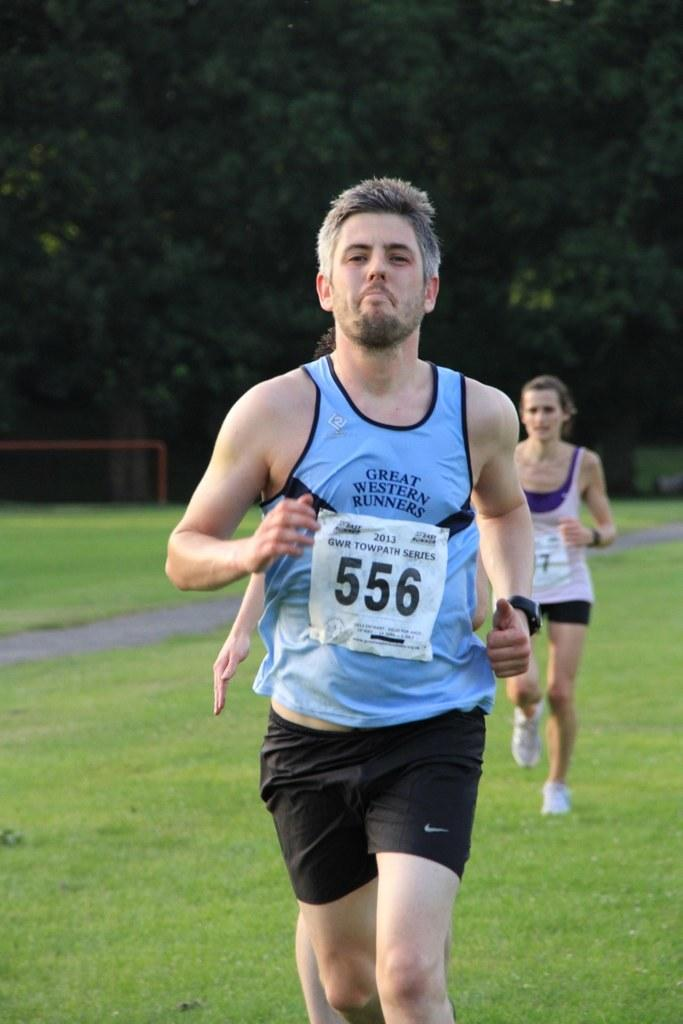Provide a one-sentence caption for the provided image. A man running in a marathon with identification code 556. 